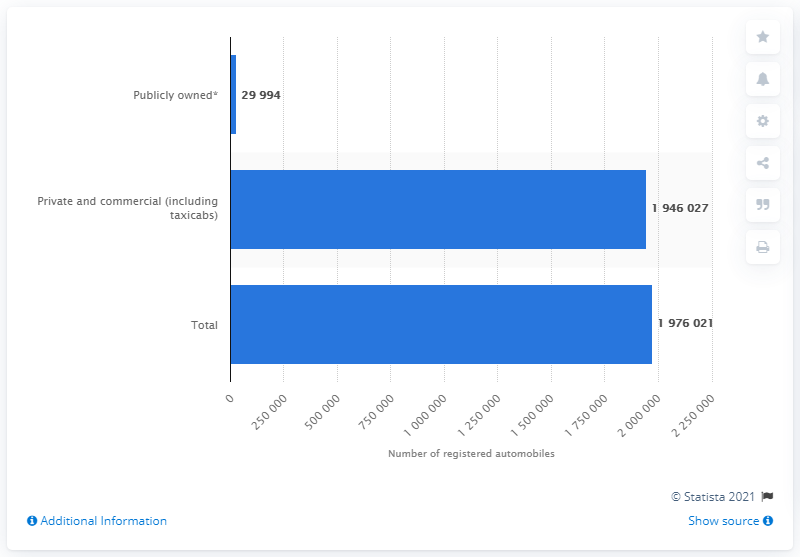Mention a couple of crucial points in this snapshot. In 2016, a total of 1,946,027 private and commercial automobiles were registered in the state of Maryland. 